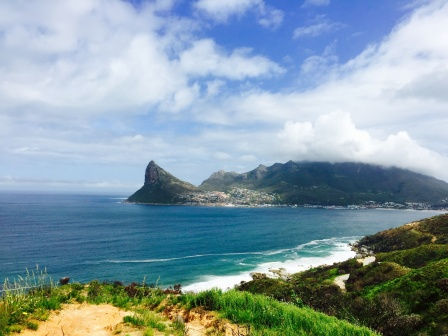What is this photo about? The image showcases a breathtaking coastal landscape bathed in bright sunlight. Dominating the lower half is a vast expanse of the deep blue ocean, its surface adorned with white waves crashing against the shore. The middle of the frame displays a stark contrast with lush green, rocky terrain that forms the coastline, where a small town nestles comfortably among the green hills. Though its exact details are not clear from this high vantage point, the town adds an element of human presence amidst nature's grandeur. The upper portion is occupied by a serene blue sky, dotted with fluffy white clouds that float lazily. The sun, though not visible, illuminates the scene with a warm, radiant light, creating a harmonious composition of ocean, coastline, town, hills, and sky. The image is calm, picturesque, and free from any discernible text or countable objects, celebrating the peaceful coexistence of natural elements and human habitation. 